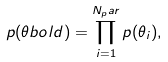Convert formula to latex. <formula><loc_0><loc_0><loc_500><loc_500>p ( \theta b o l d ) = \prod _ { i = 1 } ^ { N _ { p } a r } p ( \theta _ { i } ) ,</formula> 